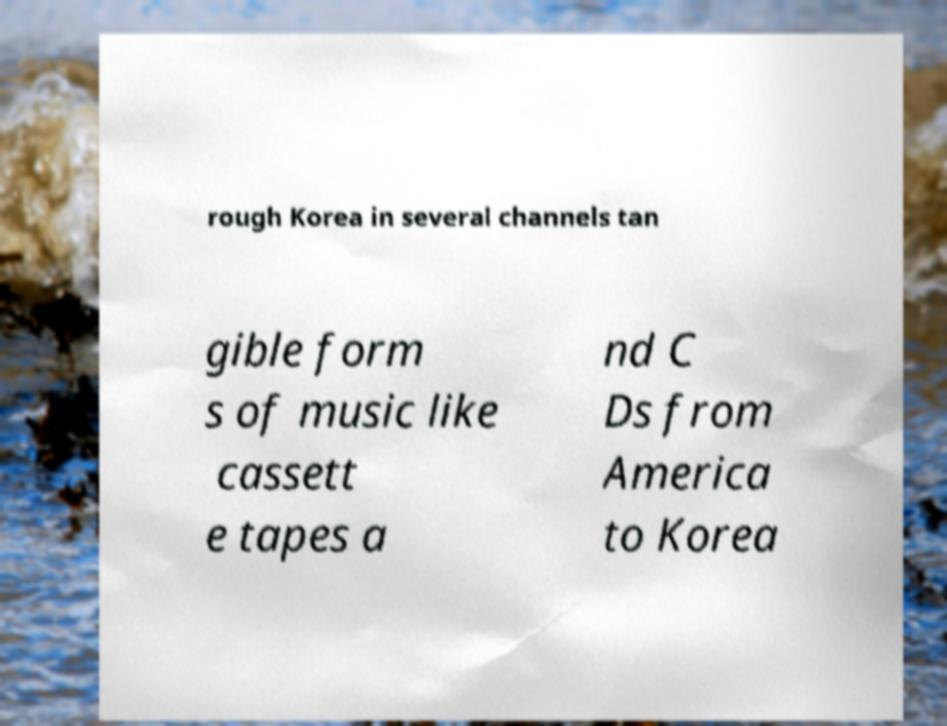I need the written content from this picture converted into text. Can you do that? rough Korea in several channels tan gible form s of music like cassett e tapes a nd C Ds from America to Korea 